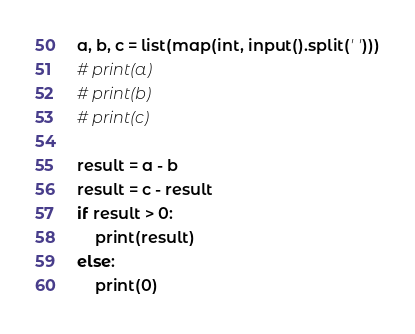Convert code to text. <code><loc_0><loc_0><loc_500><loc_500><_Python_>a, b, c = list(map(int, input().split(' ')))
# print(a)
# print(b)
# print(c)

result = a - b
result = c - result
if result > 0:
    print(result)
else:
    print(0)</code> 